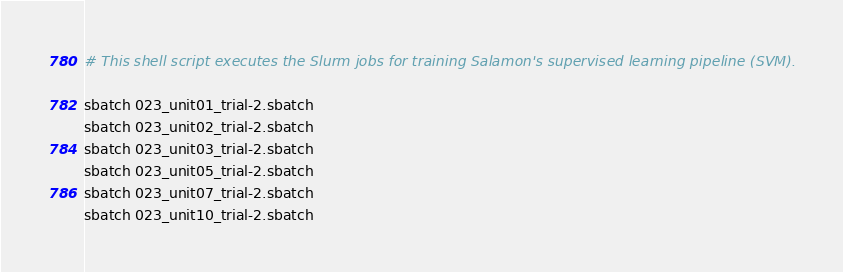<code> <loc_0><loc_0><loc_500><loc_500><_Bash_># This shell script executes the Slurm jobs for training Salamon's supervised learning pipeline (SVM).

sbatch 023_unit01_trial-2.sbatch
sbatch 023_unit02_trial-2.sbatch
sbatch 023_unit03_trial-2.sbatch
sbatch 023_unit05_trial-2.sbatch
sbatch 023_unit07_trial-2.sbatch
sbatch 023_unit10_trial-2.sbatch
</code> 